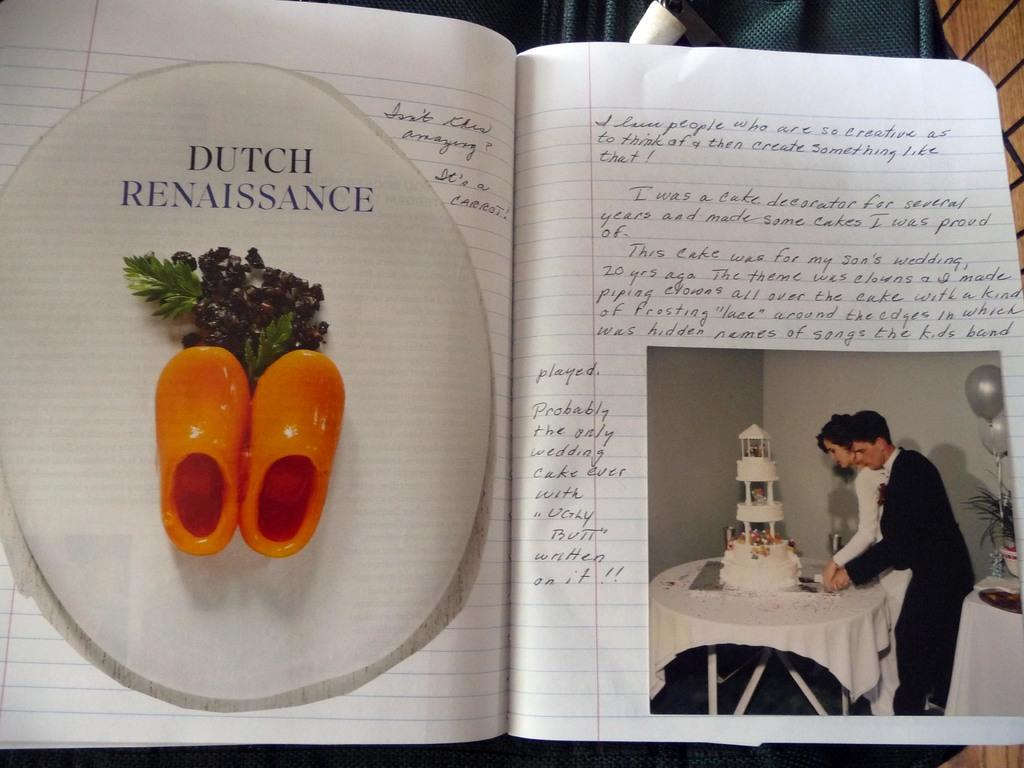What object is present in the image that contains written information? There is a book in the image that contains written information. What can be found within the book? The book contains a painting. What is depicted in the painting? The painting depicts a man and woman. What are the man and woman doing in the painting? The man and woman are cutting a cake in the painting. Where is the cake located in the painting? The cake is on a table in the painting. What year is the step depicted in the image? There is no step present in the image, and therefore no year can be associated with it. 